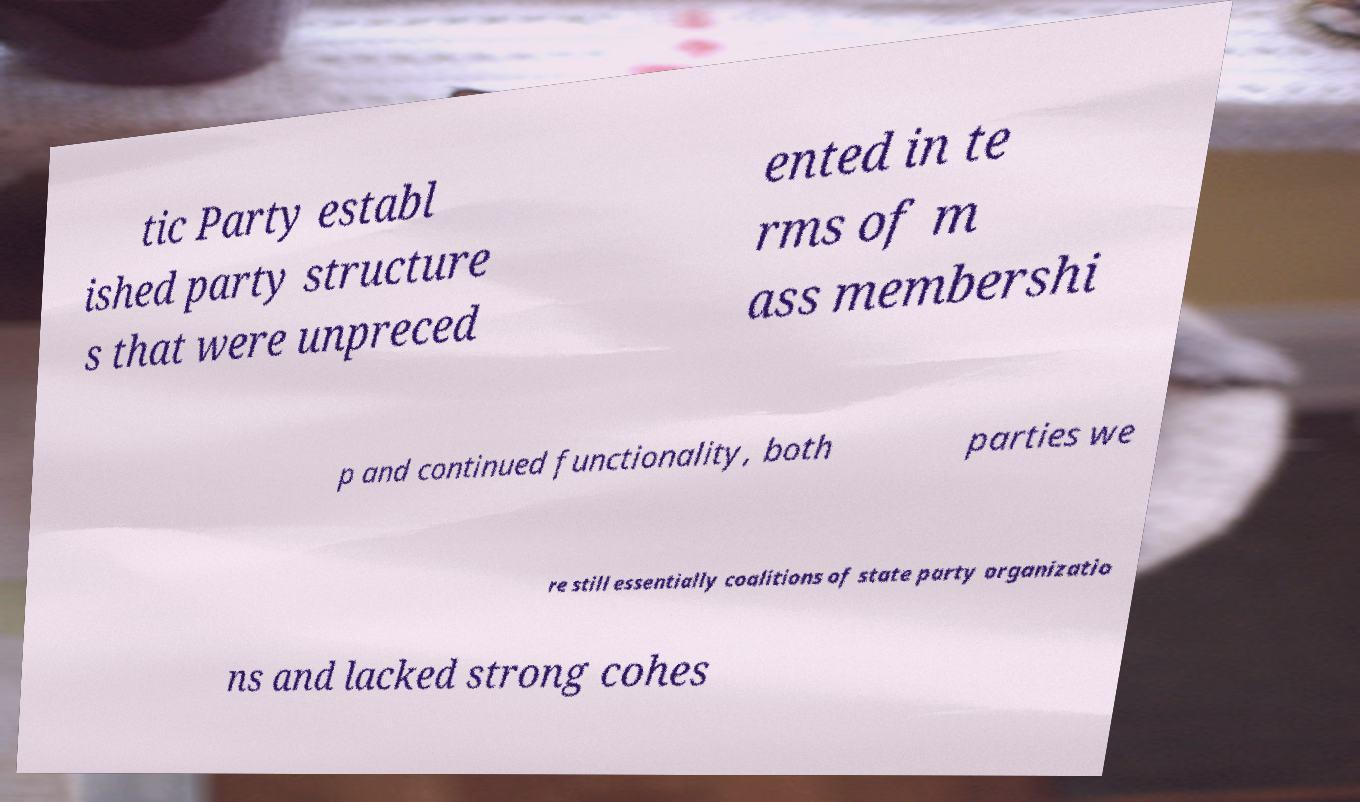Please read and relay the text visible in this image. What does it say? tic Party establ ished party structure s that were unpreced ented in te rms of m ass membershi p and continued functionality, both parties we re still essentially coalitions of state party organizatio ns and lacked strong cohes 